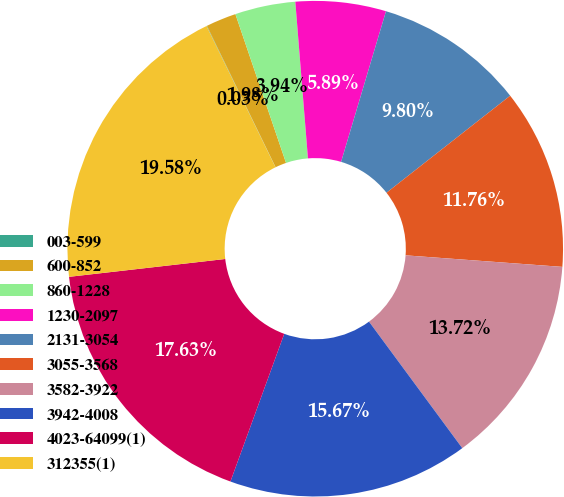<chart> <loc_0><loc_0><loc_500><loc_500><pie_chart><fcel>003-599<fcel>600-852<fcel>860-1228<fcel>1230-2097<fcel>2131-3054<fcel>3055-3568<fcel>3582-3922<fcel>3942-4008<fcel>4023-64099(1)<fcel>312355(1)<nl><fcel>0.03%<fcel>1.98%<fcel>3.94%<fcel>5.89%<fcel>9.8%<fcel>11.76%<fcel>13.72%<fcel>15.67%<fcel>17.63%<fcel>19.58%<nl></chart> 